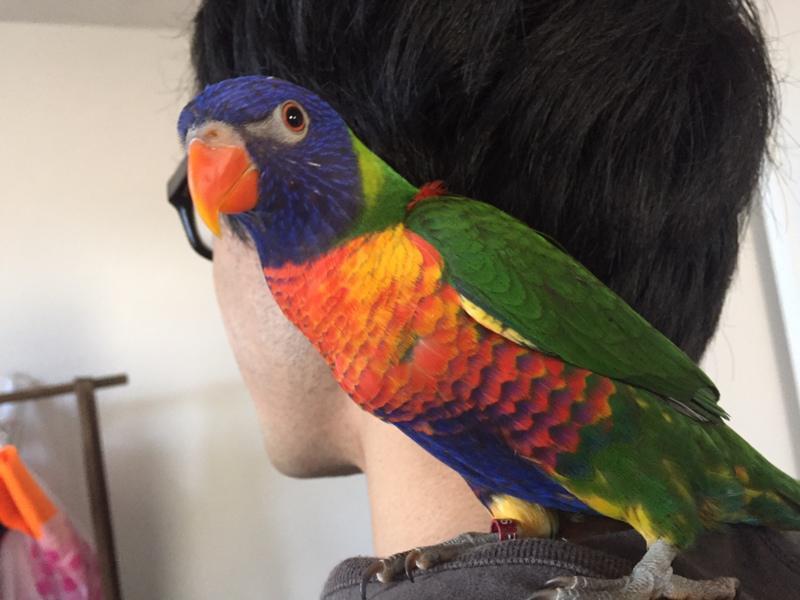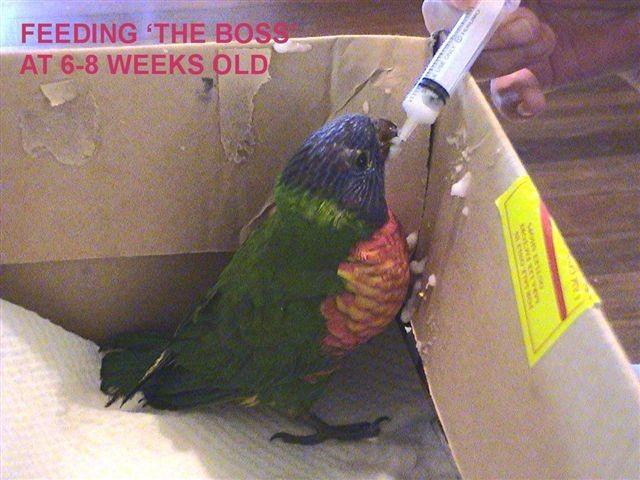The first image is the image on the left, the second image is the image on the right. Analyze the images presented: Is the assertion "The bird in the image on the left is standing on a person." valid? Answer yes or no. Yes. The first image is the image on the left, the second image is the image on the right. Examine the images to the left and right. Is the description "Left image shows a colorful parrot near a person's head." accurate? Answer yes or no. Yes. 